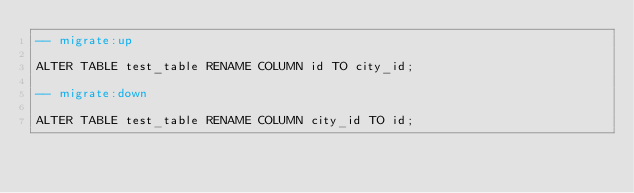Convert code to text. <code><loc_0><loc_0><loc_500><loc_500><_SQL_>-- migrate:up
   
ALTER TABLE test_table RENAME COLUMN id TO city_id;

-- migrate:down

ALTER TABLE test_table RENAME COLUMN city_id TO id;
</code> 